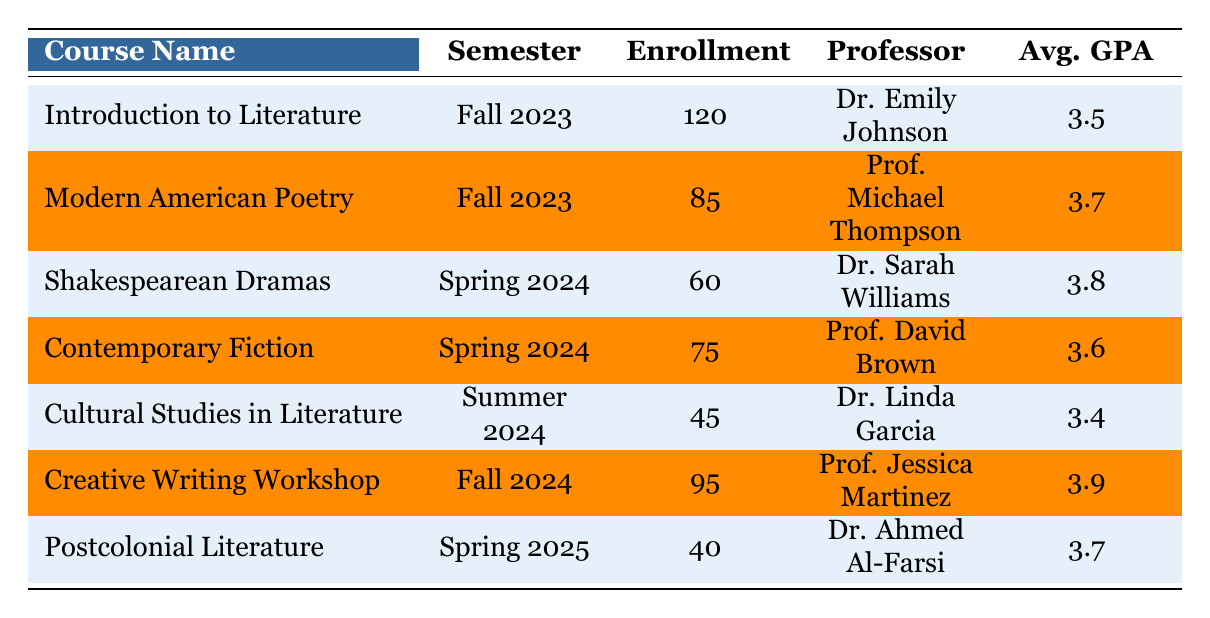What is the enrollment number for 'Modern American Poetry'? The table lists 'Modern American Poetry' under the Fall 2023 semester with an enrollment of 85.
Answer: 85 Which course has the highest average GPA? The average GPA for 'Creative Writing Workshop' is 3.9, which is higher than any other course listed in the table.
Answer: Creative Writing Workshop How many students are enrolled in total across all courses for the Fall 2023 semester? The table shows two courses for Fall 2023: 'Introduction to Literature' with 120 students and 'Modern American Poetry' with 85 students. Summing these gives 120 + 85 = 205.
Answer: 205 Is the enrollment for 'Cultural Studies in Literature' higher than that for 'Shakespearean Dramas'? 'Cultural Studies in Literature' has an enrollment of 45 while 'Shakespearean Dramas' has 60. Since 45 is less than 60, the statement is false.
Answer: No What is the average GPA of courses offered in Spring 2024? The Spring 2024 semester includes 'Shakespearean Dramas' with an average GPA of 3.8 and 'Contemporary Fiction' with an average GPA of 3.6. To find the average: (3.8 + 3.6) / 2 = 3.7.
Answer: 3.7 Which professor teaches 'Creative Writing Workshop'? The table states that 'Creative Writing Workshop' is taught by Prof. Jessica Martinez.
Answer: Prof. Jessica Martinez How many students are enrolled in courses for the Spring semester (Spring 2024 and Spring 2025)? The Spring 2024 semester has 'Shakespearean Dramas' with 60 students and 'Contemporary Fiction' with 75 students. The Spring 2025 semester has 'Postcolonial Literature' with 40 students. Total enrollment is 60 + 75 + 40 = 175.
Answer: 175 Does 'Cultural Studies in Literature' have a higher enrollment than 'Creative Writing Workshop'? 'Cultural Studies in Literature' has an enrollment of 45, and 'Creative Writing Workshop' has 95. Since 45 is less than 95, the statement is false.
Answer: No Which course is taught by Dr. Sarah Williams? According to the table, 'Shakespearean Dramas' is taught by Dr. Sarah Williams.
Answer: Shakespearean Dramas 